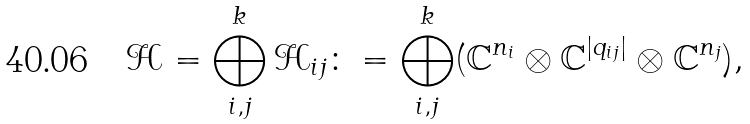<formula> <loc_0><loc_0><loc_500><loc_500>\mathcal { H } = \bigoplus _ { i , j } ^ { k } \mathcal { H } _ { i j } \colon = \bigoplus _ { i , j } ^ { k } ( { \mathbb { C } } ^ { { n } _ { i } } \otimes { \mathbb { C } } ^ { | { q } _ { i j } | } \otimes { \mathbb { C } } ^ { { n } _ { j } } ) ,</formula> 